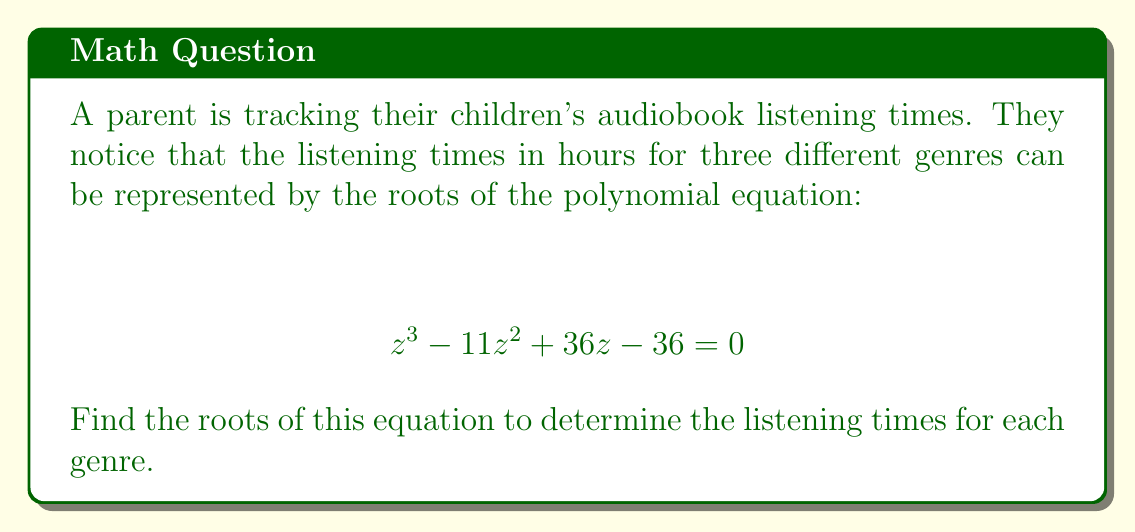Solve this math problem. To find the roots of the polynomial equation, we'll use the rational root theorem and synthetic division.

1) First, let's list the possible rational roots. The possible roots are the factors of the constant term (36) divided by the factors of the leading coefficient (1):
   $\pm 1, \pm 2, \pm 3, \pm 4, \pm 6, \pm 9, \pm 12, \pm 18, \pm 36$

2) Now, let's use synthetic division to test these potential roots:

   Testing $z = 3$:
   $$
   \begin{array}{r|r}
   1 & -11 & 36 & -36 \\
   & 3 & -24 & 36 \\
   \hline
   1 & -8 & 12 & 0
   \end{array}
   $$

   We found our first root: $z = 3$

3) Now we can factor out $(z - 3)$ and continue:
   $$ (z - 3)(z^2 - 8z + 12) = 0 $$

4) The quadratic factor $z^2 - 8z + 12$ can be solved using the quadratic formula:
   $$ z = \frac{-b \pm \sqrt{b^2 - 4ac}}{2a} $$
   Here, $a = 1$, $b = -8$, and $c = 12$

5) Plugging in these values:
   $$ z = \frac{8 \pm \sqrt{64 - 48}}{2} = \frac{8 \pm 4}{2} $$

6) This gives us our other two roots:
   $$ z = \frac{8 + 4}{2} = 6 \quad \text{and} \quad z = \frac{8 - 4}{2} = 2 $$

Therefore, the three roots of the equation are 3, 6, and 2.
Answer: The roots of the equation are 2, 3, and 6. These represent the audiobook listening times in hours for the three different genres. 